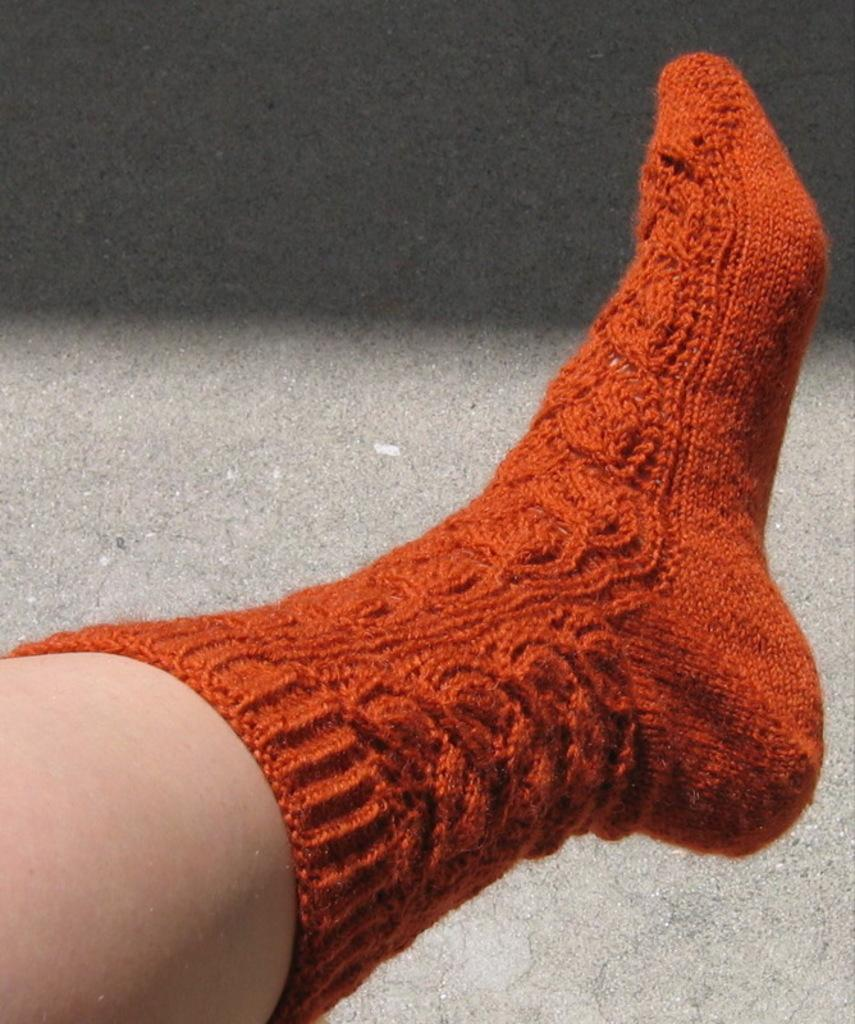Who or what is the main subject in the image? There is a person in the image. What is the person wearing on their leg? The person is wearing a sock on their leg. What can be seen beneath the person in the image? The floor is visible in the image. What type of frame is used to display the person in the image? There is no frame present in the image; it is a photograph or digital image. What tool is the person using to sort items in the image? There is no tool or sorting activity depicted in the image. 